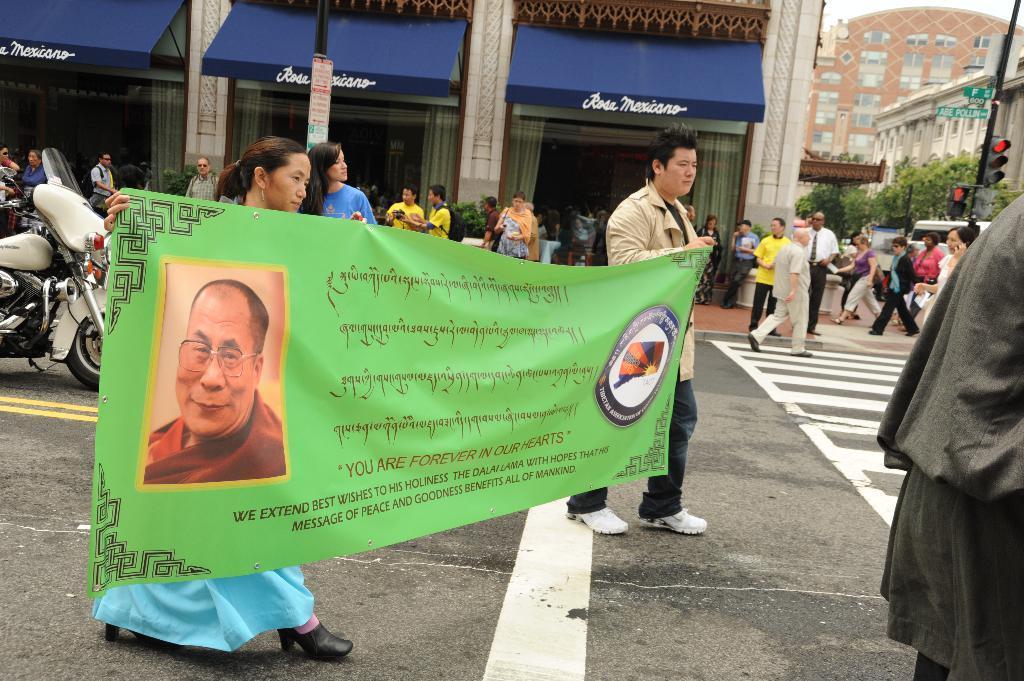Please provide a concise description of this image. The picture is taken outside a city on the streets. In the foreground of the picture there are people, road, a banner and a motorbike. In the background towards right there are buildings, trees, signals, people and a vehicle. Towards left there is a building. 